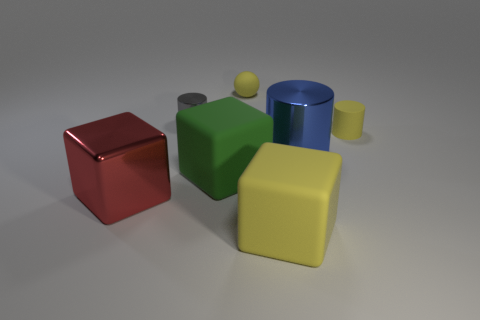Subtract 1 cubes. How many cubes are left? 2 Subtract all matte blocks. How many blocks are left? 1 Add 1 tiny gray objects. How many objects exist? 8 Subtract all spheres. How many objects are left? 6 Subtract all purple cylinders. Subtract all yellow cubes. How many cylinders are left? 3 Subtract all large green matte blocks. Subtract all small gray cylinders. How many objects are left? 5 Add 4 red shiny things. How many red shiny things are left? 5 Add 4 big yellow matte blocks. How many big yellow matte blocks exist? 5 Subtract 1 green blocks. How many objects are left? 6 